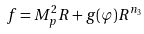Convert formula to latex. <formula><loc_0><loc_0><loc_500><loc_500>f = M _ { p } ^ { 2 } R + g ( \varphi ) R ^ { n _ { 3 } }</formula> 